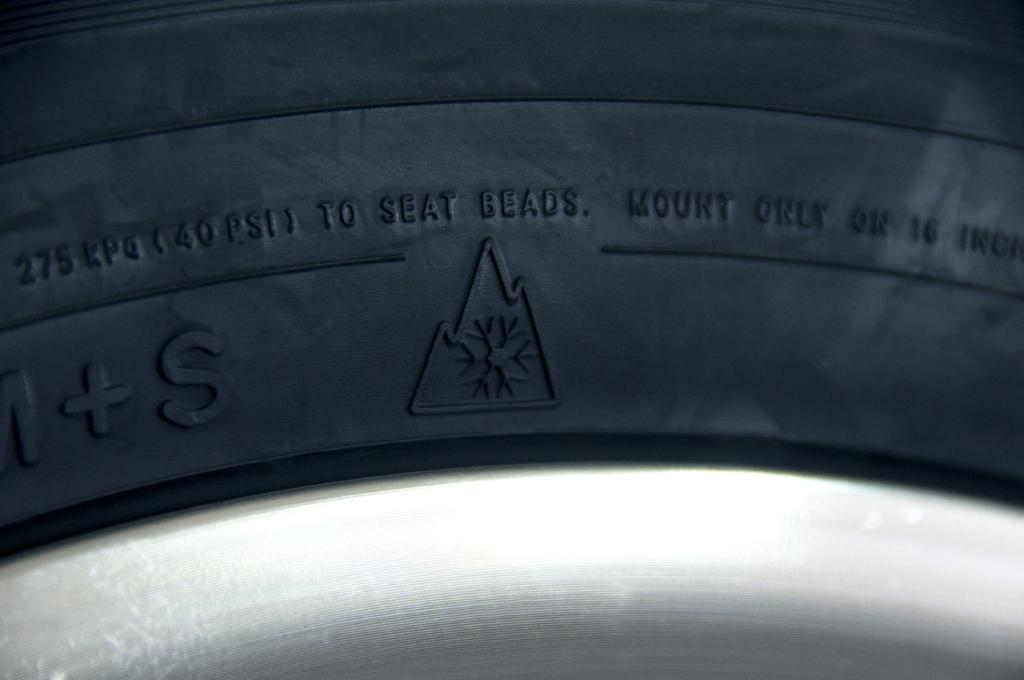What object can be seen in the image? There is a tyre in the image. What is written or printed on the tyre? There is text on the tyre. What type of band is performing in the image? There is no band present in the image; it only features a tyre with text on it. 